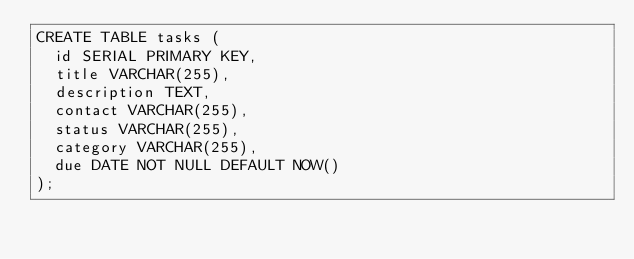<code> <loc_0><loc_0><loc_500><loc_500><_SQL_>CREATE TABLE tasks (
  id SERIAL PRIMARY KEY,
  title VARCHAR(255),
  description TEXT,
  contact VARCHAR(255),
  status VARCHAR(255),
  category VARCHAR(255),
  due DATE NOT NULL DEFAULT NOW()
);
</code> 